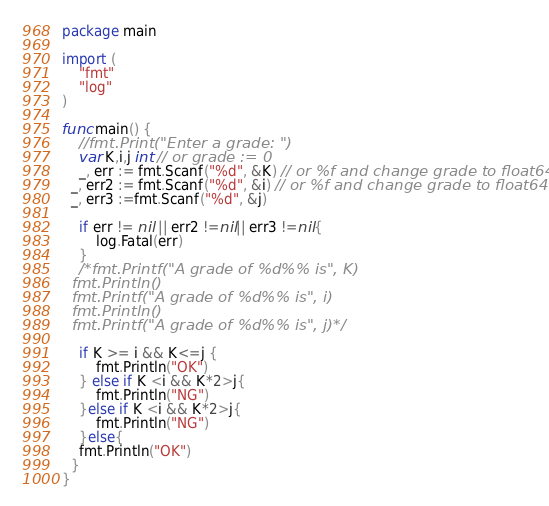Convert code to text. <code><loc_0><loc_0><loc_500><loc_500><_Go_>package main

import (
	"fmt"
	"log"
)

func main() {
	//fmt.Print("Enter a grade: ")
	var K,i,j int // or grade := 0
	_, err := fmt.Scanf("%d", &K) // or %f and change grade to float64
  _, err2 := fmt.Scanf("%d", &i) // or %f and change grade to float64
  _, err3 :=fmt.Scanf("%d", &j)

	if err != nil || err2 !=nil|| err3 !=nil{
		log.Fatal(err)
	}
	/*fmt.Printf("A grade of %d%% is", K)
  fmt.Println()
  fmt.Printf("A grade of %d%% is", i)
  fmt.Println()
  fmt.Printf("A grade of %d%% is", j)*/

	if K >= i && K<=j {
		fmt.Println("OK")
	} else if K <i && K*2>j{
		fmt.Println("NG")
	}else if K <i && K*2>j{
		fmt.Println("NG")
	}else{
    fmt.Println("OK")
  }
}</code> 